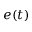Convert formula to latex. <formula><loc_0><loc_0><loc_500><loc_500>e ( t )</formula> 